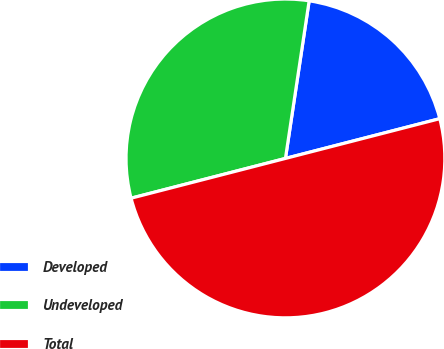Convert chart to OTSL. <chart><loc_0><loc_0><loc_500><loc_500><pie_chart><fcel>Developed<fcel>Undeveloped<fcel>Total<nl><fcel>18.61%<fcel>31.39%<fcel>50.0%<nl></chart> 